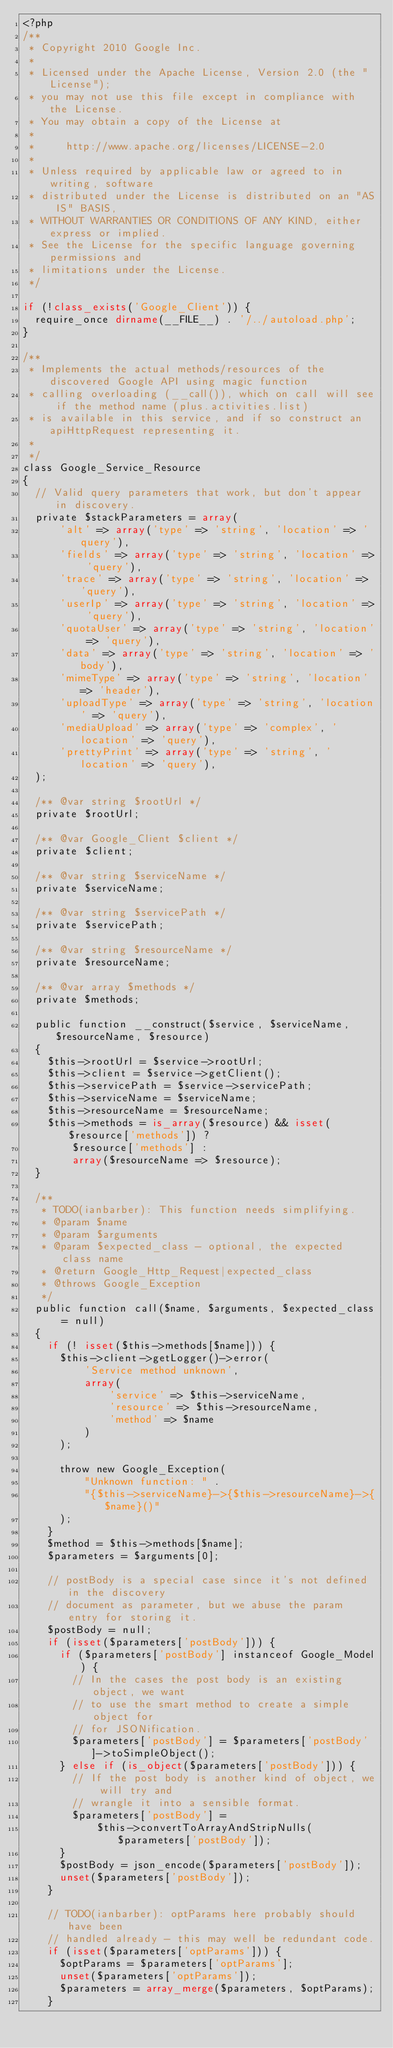<code> <loc_0><loc_0><loc_500><loc_500><_PHP_><?php
/**
 * Copyright 2010 Google Inc.
 *
 * Licensed under the Apache License, Version 2.0 (the "License");
 * you may not use this file except in compliance with the License.
 * You may obtain a copy of the License at
 *
 *     http://www.apache.org/licenses/LICENSE-2.0
 *
 * Unless required by applicable law or agreed to in writing, software
 * distributed under the License is distributed on an "AS IS" BASIS,
 * WITHOUT WARRANTIES OR CONDITIONS OF ANY KIND, either express or implied.
 * See the License for the specific language governing permissions and
 * limitations under the License.
 */

if (!class_exists('Google_Client')) {
  require_once dirname(__FILE__) . '/../autoload.php';
}

/**
 * Implements the actual methods/resources of the discovered Google API using magic function
 * calling overloading (__call()), which on call will see if the method name (plus.activities.list)
 * is available in this service, and if so construct an apiHttpRequest representing it.
 *
 */
class Google_Service_Resource
{
  // Valid query parameters that work, but don't appear in discovery.
  private $stackParameters = array(
      'alt' => array('type' => 'string', 'location' => 'query'),
      'fields' => array('type' => 'string', 'location' => 'query'),
      'trace' => array('type' => 'string', 'location' => 'query'),
      'userIp' => array('type' => 'string', 'location' => 'query'),
      'quotaUser' => array('type' => 'string', 'location' => 'query'),
      'data' => array('type' => 'string', 'location' => 'body'),
      'mimeType' => array('type' => 'string', 'location' => 'header'),
      'uploadType' => array('type' => 'string', 'location' => 'query'),
      'mediaUpload' => array('type' => 'complex', 'location' => 'query'),
      'prettyPrint' => array('type' => 'string', 'location' => 'query'),
  );

  /** @var string $rootUrl */
  private $rootUrl;

  /** @var Google_Client $client */
  private $client;

  /** @var string $serviceName */
  private $serviceName;

  /** @var string $servicePath */
  private $servicePath;

  /** @var string $resourceName */
  private $resourceName;

  /** @var array $methods */
  private $methods;

  public function __construct($service, $serviceName, $resourceName, $resource)
  {
    $this->rootUrl = $service->rootUrl;
    $this->client = $service->getClient();
    $this->servicePath = $service->servicePath;
    $this->serviceName = $serviceName;
    $this->resourceName = $resourceName;
    $this->methods = is_array($resource) && isset($resource['methods']) ?
        $resource['methods'] :
        array($resourceName => $resource);
  }

  /**
   * TODO(ianbarber): This function needs simplifying.
   * @param $name
   * @param $arguments
   * @param $expected_class - optional, the expected class name
   * @return Google_Http_Request|expected_class
   * @throws Google_Exception
   */
  public function call($name, $arguments, $expected_class = null)
  {
    if (! isset($this->methods[$name])) {
      $this->client->getLogger()->error(
          'Service method unknown',
          array(
              'service' => $this->serviceName,
              'resource' => $this->resourceName,
              'method' => $name
          )
      );

      throw new Google_Exception(
          "Unknown function: " .
          "{$this->serviceName}->{$this->resourceName}->{$name}()"
      );
    }
    $method = $this->methods[$name];
    $parameters = $arguments[0];

    // postBody is a special case since it's not defined in the discovery
    // document as parameter, but we abuse the param entry for storing it.
    $postBody = null;
    if (isset($parameters['postBody'])) {
      if ($parameters['postBody'] instanceof Google_Model) {
        // In the cases the post body is an existing object, we want
        // to use the smart method to create a simple object for
        // for JSONification.
        $parameters['postBody'] = $parameters['postBody']->toSimpleObject();
      } else if (is_object($parameters['postBody'])) {
        // If the post body is another kind of object, we will try and
        // wrangle it into a sensible format.
        $parameters['postBody'] =
            $this->convertToArrayAndStripNulls($parameters['postBody']);
      }
      $postBody = json_encode($parameters['postBody']);
      unset($parameters['postBody']);
    }

    // TODO(ianbarber): optParams here probably should have been
    // handled already - this may well be redundant code.
    if (isset($parameters['optParams'])) {
      $optParams = $parameters['optParams'];
      unset($parameters['optParams']);
      $parameters = array_merge($parameters, $optParams);
    }
</code> 